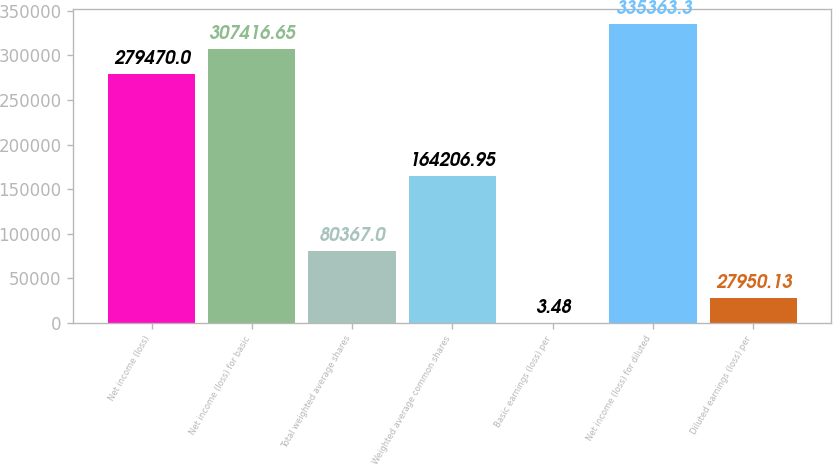Convert chart to OTSL. <chart><loc_0><loc_0><loc_500><loc_500><bar_chart><fcel>Net income (loss)<fcel>Net income (loss) for basic<fcel>Total weighted average shares<fcel>Weighted average common shares<fcel>Basic earnings (loss) per<fcel>Net income (loss) for diluted<fcel>Diluted earnings (loss) per<nl><fcel>279470<fcel>307417<fcel>80367<fcel>164207<fcel>3.48<fcel>335363<fcel>27950.1<nl></chart> 